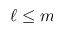Convert formula to latex. <formula><loc_0><loc_0><loc_500><loc_500>\ell \leq m</formula> 